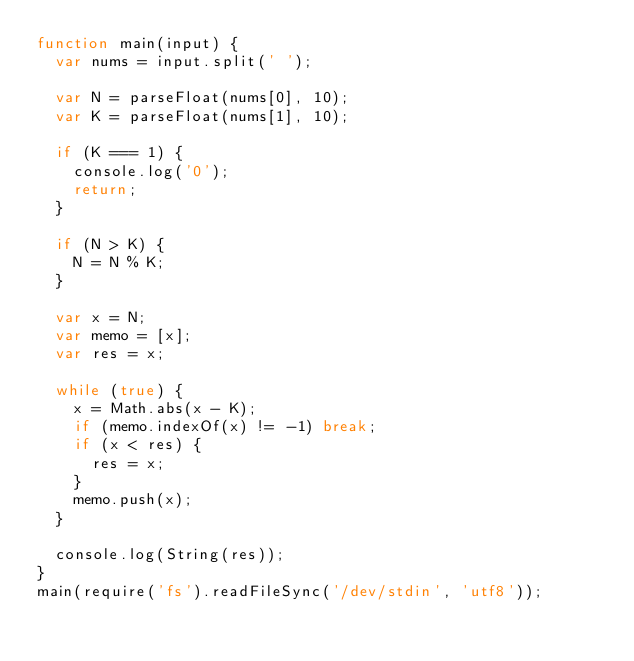Convert code to text. <code><loc_0><loc_0><loc_500><loc_500><_JavaScript_>function main(input) {
  var nums = input.split(' ');

  var N = parseFloat(nums[0], 10);
  var K = parseFloat(nums[1], 10);

  if (K === 1) {
    console.log('0');
    return;
  }

  if (N > K) {
    N = N % K;
  }

  var x = N;
  var memo = [x];
  var res = x;

  while (true) {
    x = Math.abs(x - K);
    if (memo.indexOf(x) != -1) break;
    if (x < res) {
      res = x;
    }
    memo.push(x);
  }

  console.log(String(res));
}
main(require('fs').readFileSync('/dev/stdin', 'utf8'));
</code> 